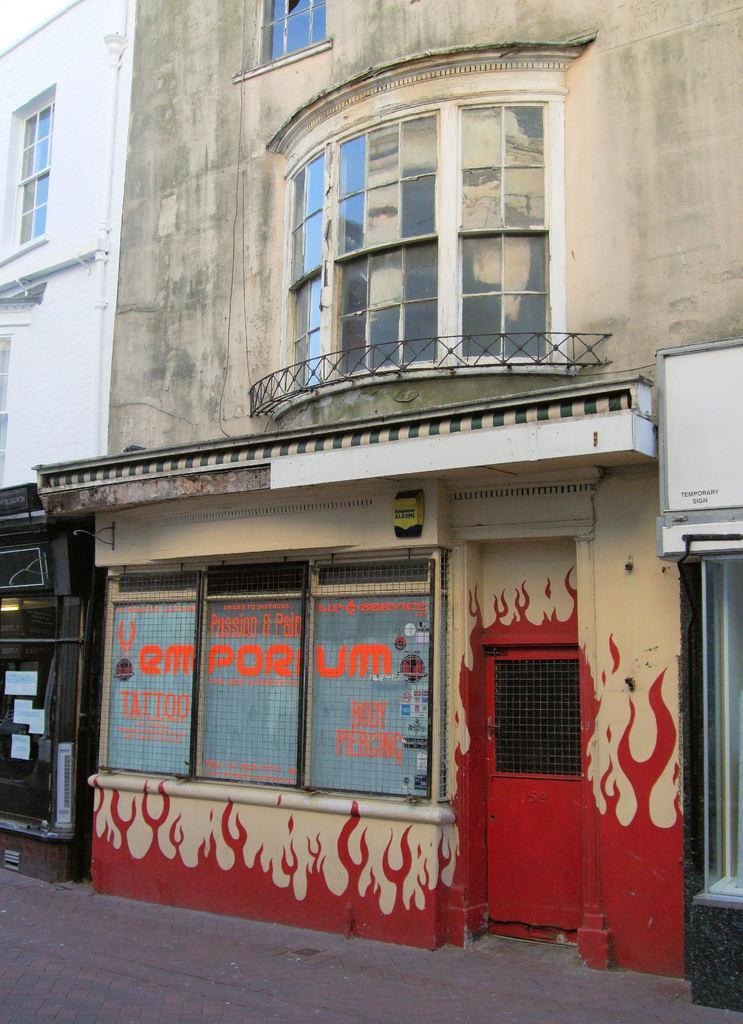Please provide a concise description of this image. there is a old building and i can see red color door were we can get access to go inside and also i can see painting on the wall which is in red and i can also read and i can see building designed with the windows which is designed with glass and i can see grill and also i can also see window glass which is broken , the window glass is broken , this is very old building next to it i can a white color building and a window which is designed with a glass. 